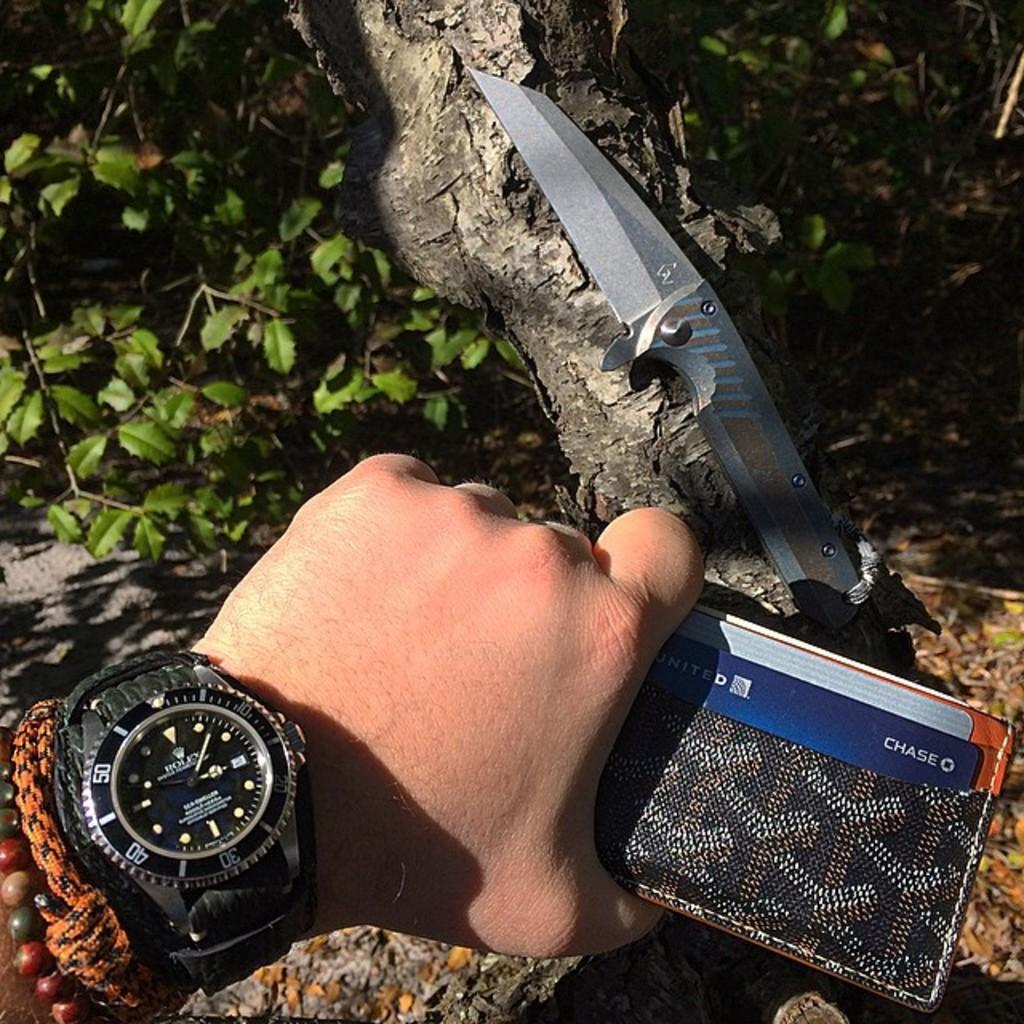<image>
Share a concise interpretation of the image provided. A person is holding a wallet containing a Chase card next to a large knife. 